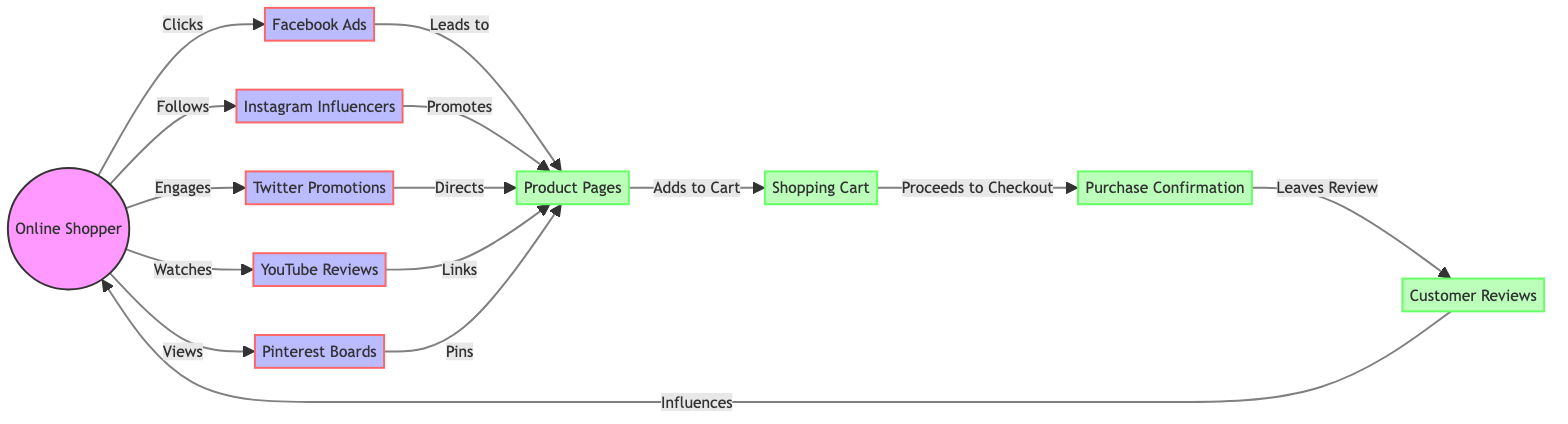What is the total number of nodes in the diagram? Upon reviewing the diagram, I count a total of ten nodes listed, which include both social media influences and e-commerce elements.
Answer: 10 How many edges connect the online shopper to social media platforms? In the diagram, the online shopper connects to five different social media platforms through clicks, follows, engages, watches, and views, as indicated by five directed edges.
Answer: 5 Which node does the Facebook ads lead to? Following the arrow in the diagram, it is evident that Facebook ads direct the flow to product pages, indicated by the edge labeled "Leads to".
Answer: Product Pages What action does the shopping cart perform before the purchase confirmation? The diagram shows that the action taken by the shopping cart is to proceed to checkout, as shown by the edge "Proceeds to Checkout" leading to the purchase confirmation node.
Answer: Proceeds to Checkout Which social media platform does the online shopper engage with the most based on connections? Analyzing the diagram, the online shopper engages with Facebook ads, Instagram influencers, Twitter promotions, YouTube reviews, and Pinterest boards, but none have a direct indication of being "the most". Each is unique in connection. The answer can be subjective; however, all are engaged equally.
Answer: All Equally What relationship exists between customer reviews and the online shopper? The diagram indicates that customer reviews influence the online shopper, as represented by the directed edge labeled "Influences".
Answer: Influences Which node receives links from YouTube reviews? Following the paths in the diagram, the YouTube reviews link to the product pages, as depicted by the edge labeled "Links".
Answer: Product Pages How many direct connections does the product pages have? By examining the diagram, the product pages have five direct connections leading from the various social media sources that promote or direct to them.
Answer: 5 What comes after adding to cart in the shopping process depicted in the diagram? The process flow from the shopping cart indicates that after adding to cart, the next step is to proceed to checkout, reflecting the Sequential action in the shopping process.
Answer: Proceeds to Checkout 